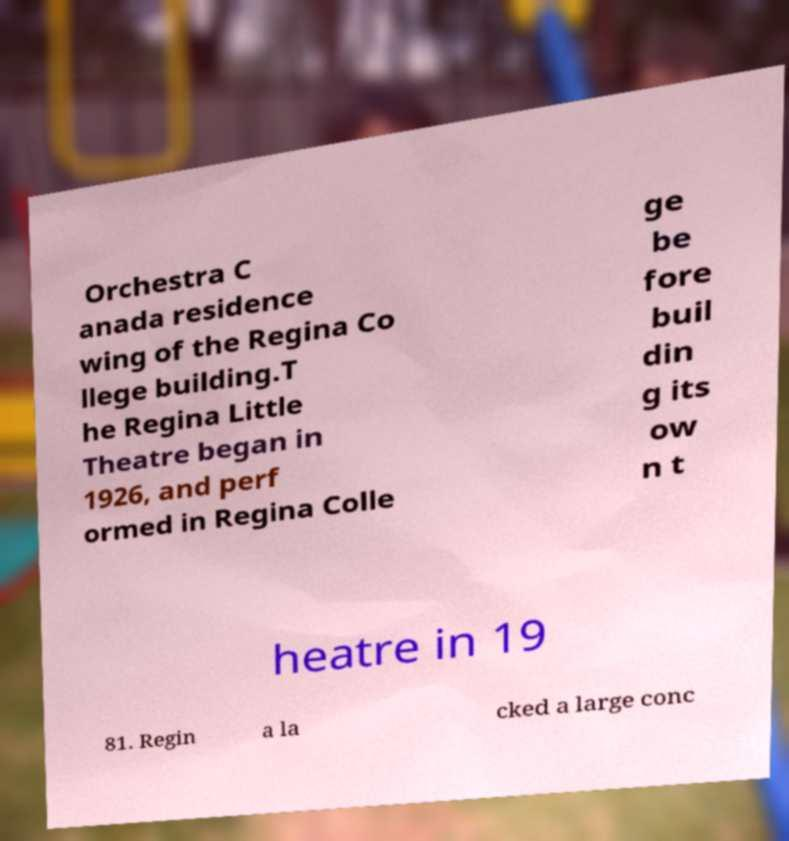Can you accurately transcribe the text from the provided image for me? Orchestra C anada residence wing of the Regina Co llege building.T he Regina Little Theatre began in 1926, and perf ormed in Regina Colle ge be fore buil din g its ow n t heatre in 19 81. Regin a la cked a large conc 